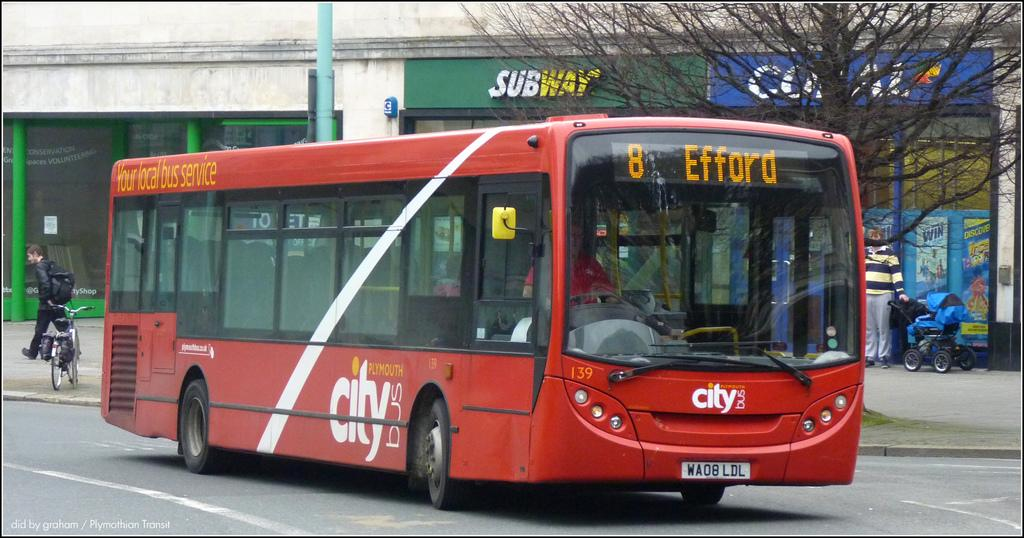<image>
Provide a brief description of the given image. the number 8 city bus going to efford 